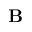<formula> <loc_0><loc_0><loc_500><loc_500>B</formula> 